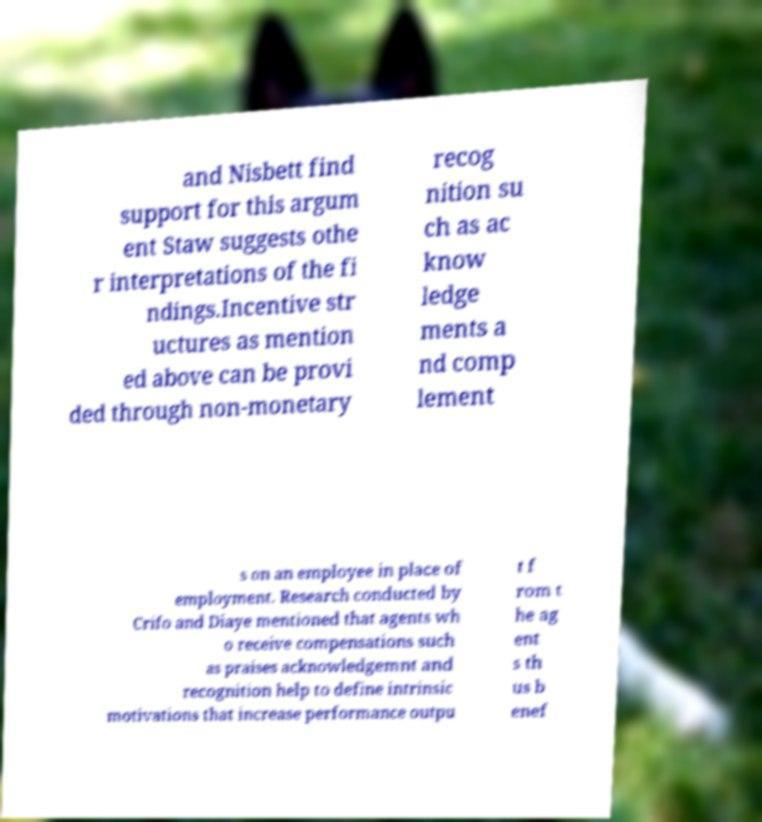For documentation purposes, I need the text within this image transcribed. Could you provide that? and Nisbett find support for this argum ent Staw suggests othe r interpretations of the fi ndings.Incentive str uctures as mention ed above can be provi ded through non-monetary recog nition su ch as ac know ledge ments a nd comp lement s on an employee in place of employment. Research conducted by Crifo and Diaye mentioned that agents wh o receive compensations such as praises acknowledgemnt and recognition help to define intrinsic motivations that increase performance outpu t f rom t he ag ent s th us b enef 